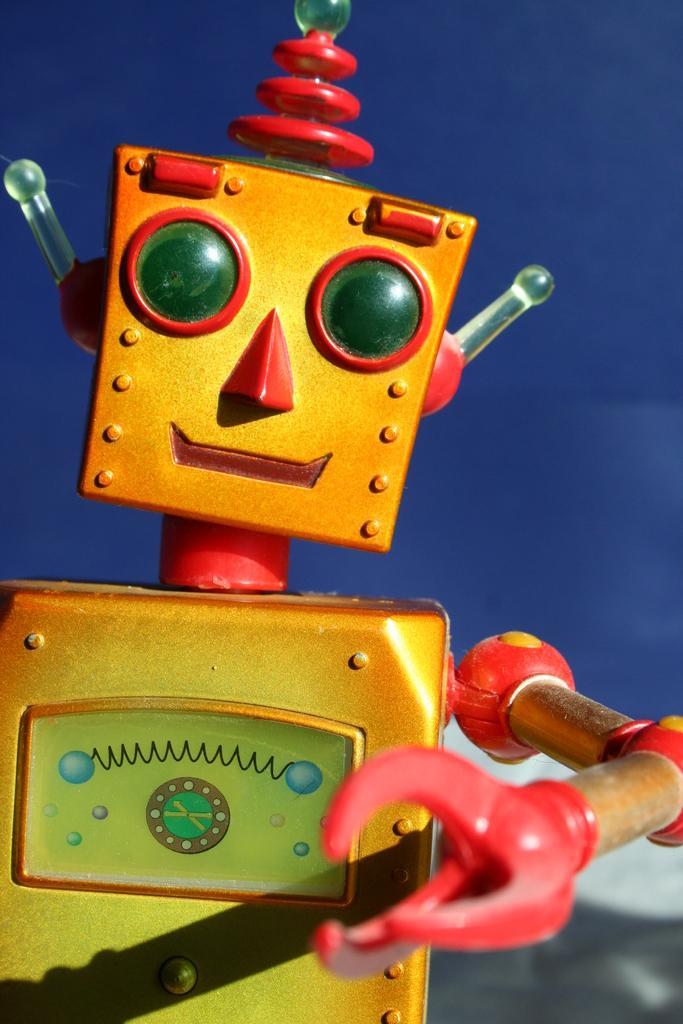Can you describe this image briefly? In this picture we can see a toy in the front, there is a blue color background. 